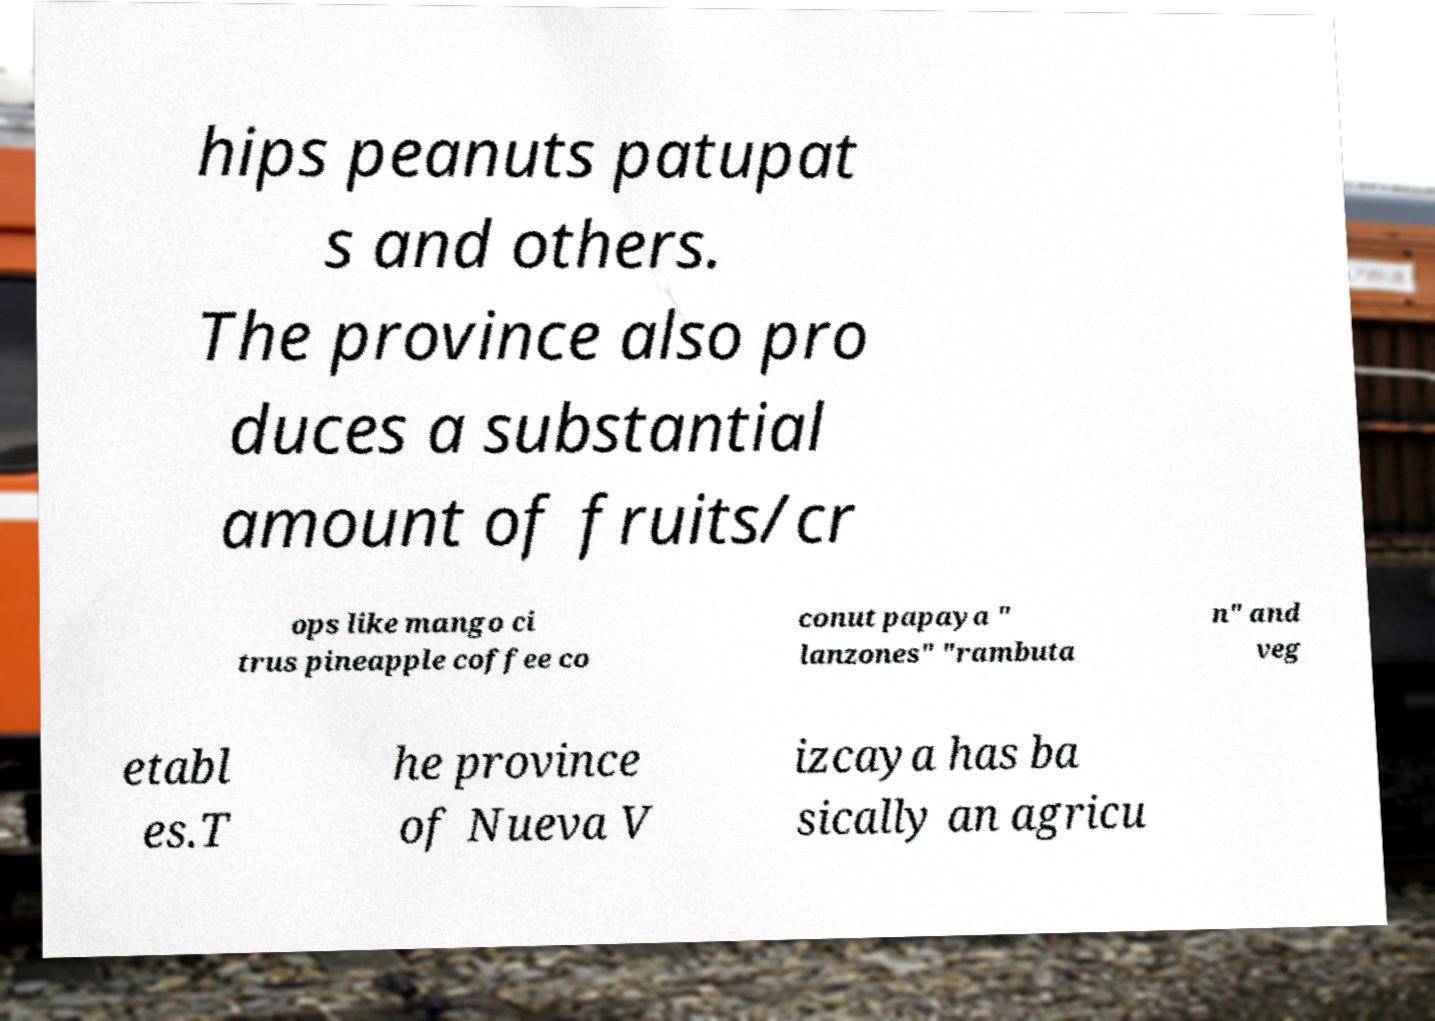Can you read and provide the text displayed in the image?This photo seems to have some interesting text. Can you extract and type it out for me? hips peanuts patupat s and others. The province also pro duces a substantial amount of fruits/cr ops like mango ci trus pineapple coffee co conut papaya " lanzones" "rambuta n" and veg etabl es.T he province of Nueva V izcaya has ba sically an agricu 